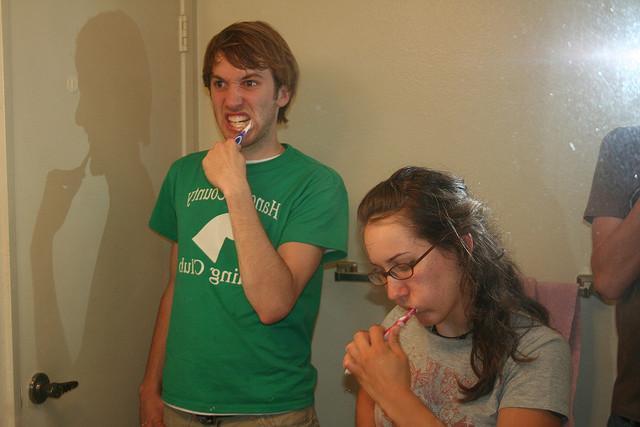How many people are visible?
Give a very brief answer. 3. How many people are in this photo?
Give a very brief answer. 3. How many rings does she have on her fingers?
Give a very brief answer. 0. How many of the people have long hair?
Give a very brief answer. 1. How many people are in the picture?
Give a very brief answer. 3. 